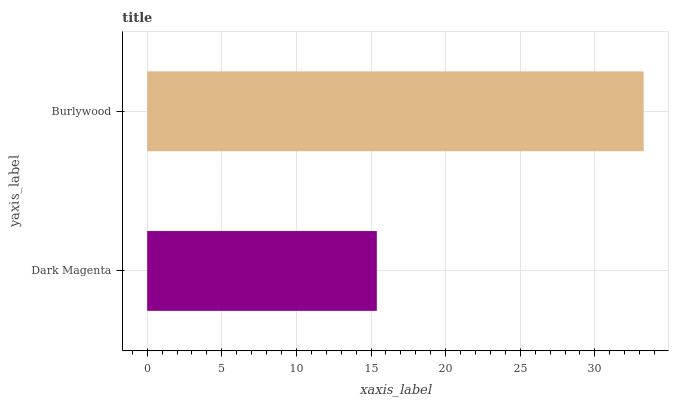Is Dark Magenta the minimum?
Answer yes or no. Yes. Is Burlywood the maximum?
Answer yes or no. Yes. Is Burlywood the minimum?
Answer yes or no. No. Is Burlywood greater than Dark Magenta?
Answer yes or no. Yes. Is Dark Magenta less than Burlywood?
Answer yes or no. Yes. Is Dark Magenta greater than Burlywood?
Answer yes or no. No. Is Burlywood less than Dark Magenta?
Answer yes or no. No. Is Burlywood the high median?
Answer yes or no. Yes. Is Dark Magenta the low median?
Answer yes or no. Yes. Is Dark Magenta the high median?
Answer yes or no. No. Is Burlywood the low median?
Answer yes or no. No. 